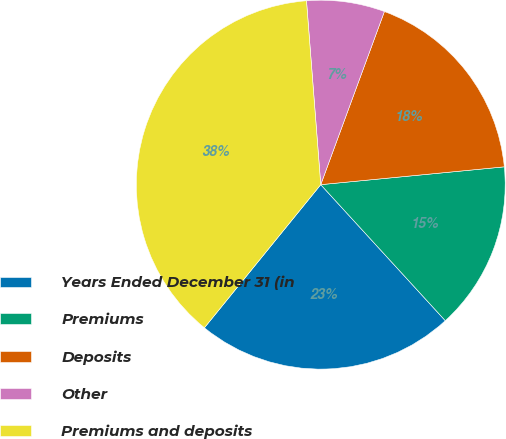<chart> <loc_0><loc_0><loc_500><loc_500><pie_chart><fcel>Years Ended December 31 (in<fcel>Premiums<fcel>Deposits<fcel>Other<fcel>Premiums and deposits<nl><fcel>22.66%<fcel>14.74%<fcel>17.85%<fcel>6.84%<fcel>37.9%<nl></chart> 